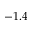<formula> <loc_0><loc_0><loc_500><loc_500>- 1 . 4</formula> 